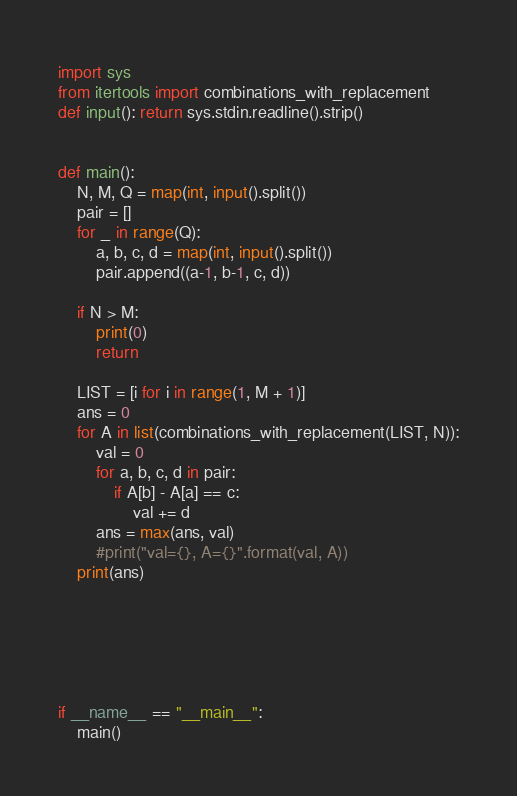<code> <loc_0><loc_0><loc_500><loc_500><_Python_>import sys
from itertools import combinations_with_replacement
def input(): return sys.stdin.readline().strip()


def main():
    N, M, Q = map(int, input().split())
    pair = []
    for _ in range(Q):
        a, b, c, d = map(int, input().split())
        pair.append((a-1, b-1, c, d))

    if N > M:
        print(0)
        return

    LIST = [i for i in range(1, M + 1)]
    ans = 0
    for A in list(combinations_with_replacement(LIST, N)):
        val = 0
        for a, b, c, d in pair:
            if A[b] - A[a] == c:
                val += d
        ans = max(ans, val)
        #print("val={}, A={}".format(val, A))
    print(ans)



    


if __name__ == "__main__":
    main()</code> 